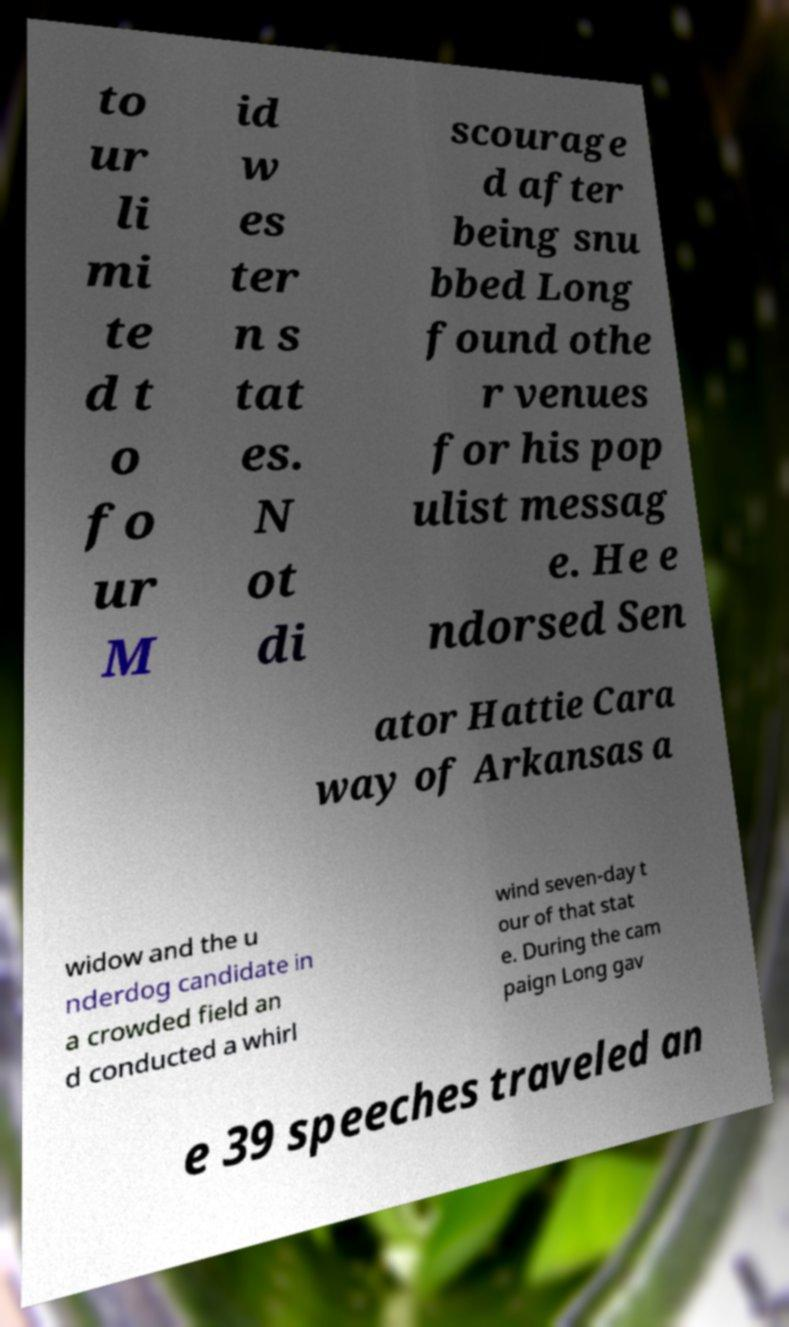Can you accurately transcribe the text from the provided image for me? to ur li mi te d t o fo ur M id w es ter n s tat es. N ot di scourage d after being snu bbed Long found othe r venues for his pop ulist messag e. He e ndorsed Sen ator Hattie Cara way of Arkansas a widow and the u nderdog candidate in a crowded field an d conducted a whirl wind seven-day t our of that stat e. During the cam paign Long gav e 39 speeches traveled an 